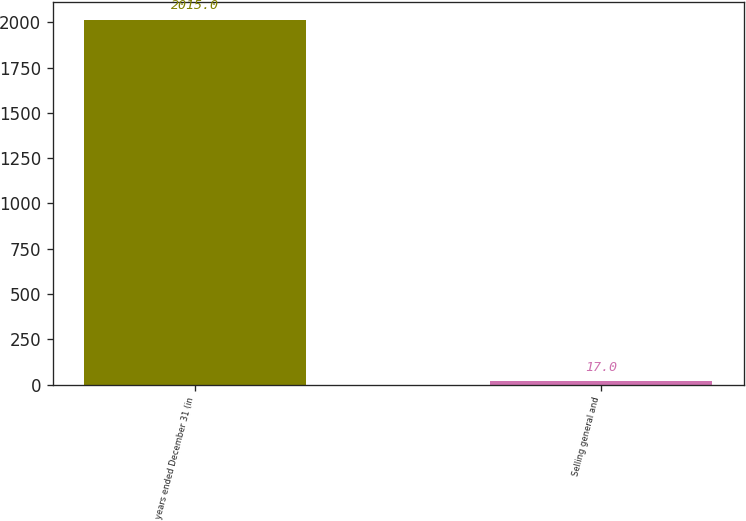Convert chart. <chart><loc_0><loc_0><loc_500><loc_500><bar_chart><fcel>years ended December 31 (in<fcel>Selling general and<nl><fcel>2015<fcel>17<nl></chart> 